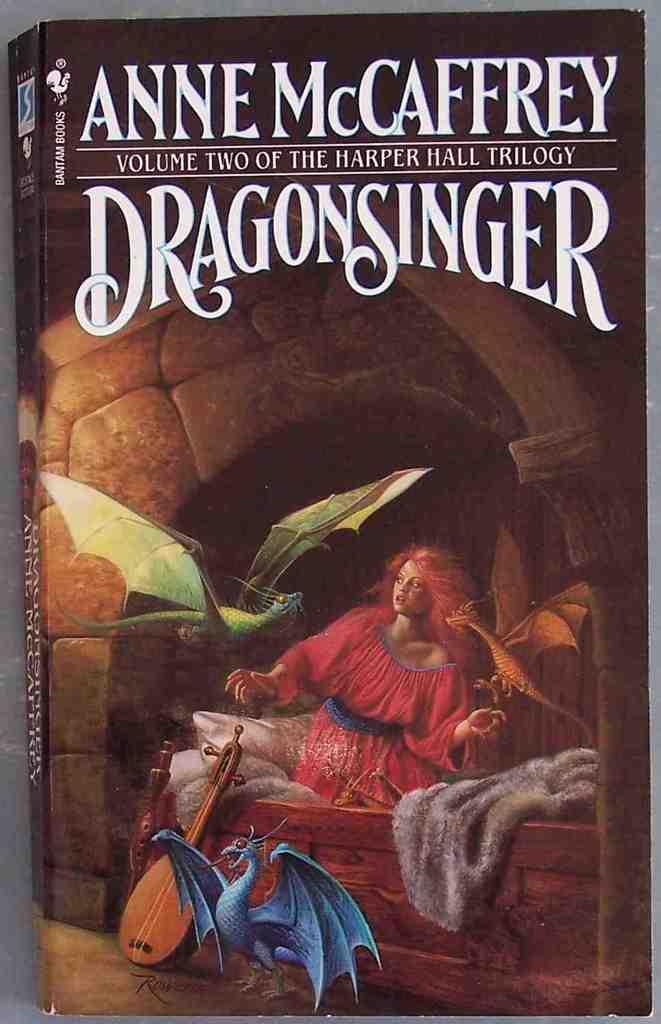Who wrote this book?
Make the answer very short. Anne mccaffrey. What is the title of the book?
Ensure brevity in your answer.  Dragonsinger. 